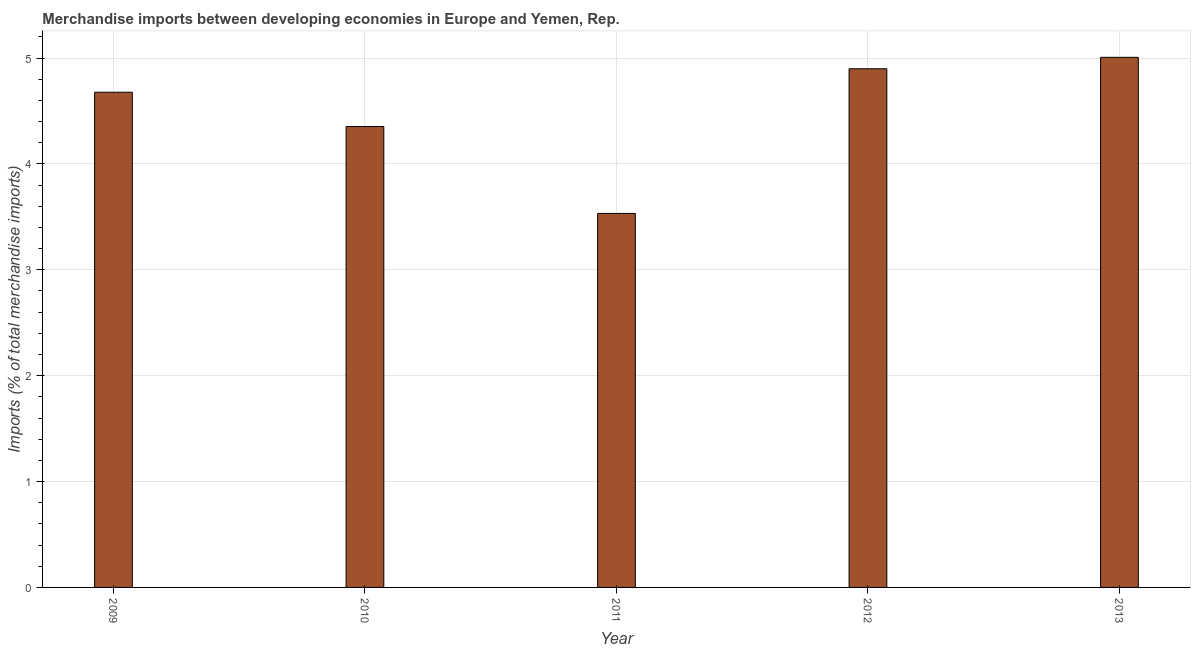Does the graph contain any zero values?
Keep it short and to the point. No. What is the title of the graph?
Provide a succinct answer. Merchandise imports between developing economies in Europe and Yemen, Rep. What is the label or title of the Y-axis?
Offer a terse response. Imports (% of total merchandise imports). What is the merchandise imports in 2009?
Offer a very short reply. 4.68. Across all years, what is the maximum merchandise imports?
Make the answer very short. 5.01. Across all years, what is the minimum merchandise imports?
Your response must be concise. 3.53. In which year was the merchandise imports minimum?
Your answer should be compact. 2011. What is the sum of the merchandise imports?
Provide a short and direct response. 22.47. What is the difference between the merchandise imports in 2012 and 2013?
Your answer should be very brief. -0.11. What is the average merchandise imports per year?
Provide a short and direct response. 4.49. What is the median merchandise imports?
Your response must be concise. 4.68. What is the ratio of the merchandise imports in 2009 to that in 2011?
Offer a very short reply. 1.32. Is the difference between the merchandise imports in 2009 and 2010 greater than the difference between any two years?
Provide a short and direct response. No. What is the difference between the highest and the second highest merchandise imports?
Your answer should be compact. 0.11. What is the difference between the highest and the lowest merchandise imports?
Provide a succinct answer. 1.47. In how many years, is the merchandise imports greater than the average merchandise imports taken over all years?
Your answer should be compact. 3. Are all the bars in the graph horizontal?
Offer a terse response. No. What is the difference between two consecutive major ticks on the Y-axis?
Offer a terse response. 1. Are the values on the major ticks of Y-axis written in scientific E-notation?
Offer a very short reply. No. What is the Imports (% of total merchandise imports) in 2009?
Your response must be concise. 4.68. What is the Imports (% of total merchandise imports) of 2010?
Your answer should be very brief. 4.35. What is the Imports (% of total merchandise imports) in 2011?
Provide a short and direct response. 3.53. What is the Imports (% of total merchandise imports) in 2012?
Your response must be concise. 4.9. What is the Imports (% of total merchandise imports) in 2013?
Your response must be concise. 5.01. What is the difference between the Imports (% of total merchandise imports) in 2009 and 2010?
Your answer should be compact. 0.32. What is the difference between the Imports (% of total merchandise imports) in 2009 and 2011?
Offer a terse response. 1.14. What is the difference between the Imports (% of total merchandise imports) in 2009 and 2012?
Provide a short and direct response. -0.22. What is the difference between the Imports (% of total merchandise imports) in 2009 and 2013?
Your response must be concise. -0.33. What is the difference between the Imports (% of total merchandise imports) in 2010 and 2011?
Keep it short and to the point. 0.82. What is the difference between the Imports (% of total merchandise imports) in 2010 and 2012?
Make the answer very short. -0.55. What is the difference between the Imports (% of total merchandise imports) in 2010 and 2013?
Your answer should be very brief. -0.65. What is the difference between the Imports (% of total merchandise imports) in 2011 and 2012?
Give a very brief answer. -1.37. What is the difference between the Imports (% of total merchandise imports) in 2011 and 2013?
Provide a short and direct response. -1.47. What is the difference between the Imports (% of total merchandise imports) in 2012 and 2013?
Provide a succinct answer. -0.11. What is the ratio of the Imports (% of total merchandise imports) in 2009 to that in 2010?
Offer a very short reply. 1.07. What is the ratio of the Imports (% of total merchandise imports) in 2009 to that in 2011?
Give a very brief answer. 1.32. What is the ratio of the Imports (% of total merchandise imports) in 2009 to that in 2012?
Your answer should be compact. 0.95. What is the ratio of the Imports (% of total merchandise imports) in 2009 to that in 2013?
Offer a terse response. 0.93. What is the ratio of the Imports (% of total merchandise imports) in 2010 to that in 2011?
Give a very brief answer. 1.23. What is the ratio of the Imports (% of total merchandise imports) in 2010 to that in 2012?
Provide a succinct answer. 0.89. What is the ratio of the Imports (% of total merchandise imports) in 2010 to that in 2013?
Provide a succinct answer. 0.87. What is the ratio of the Imports (% of total merchandise imports) in 2011 to that in 2012?
Your response must be concise. 0.72. What is the ratio of the Imports (% of total merchandise imports) in 2011 to that in 2013?
Your answer should be compact. 0.71. What is the ratio of the Imports (% of total merchandise imports) in 2012 to that in 2013?
Your response must be concise. 0.98. 